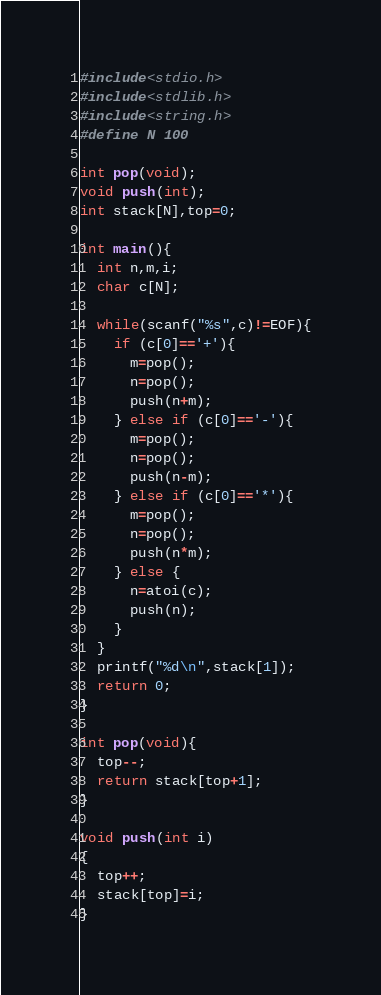Convert code to text. <code><loc_0><loc_0><loc_500><loc_500><_C_>#include<stdio.h>
#include<stdlib.h>
#include<string.h>
#define N 100
 
int pop(void);
void push(int);
int stack[N],top=0;
 
int main(){
  int n,m,i;
  char c[N];
 
  while(scanf("%s",c)!=EOF){
    if (c[0]=='+'){
      m=pop();
      n=pop();
      push(n+m);
    } else if (c[0]=='-'){
      m=pop();
      n=pop();
      push(n-m);
    } else if (c[0]=='*'){
      m=pop();
      n=pop();
      push(n*m);
    } else {
      n=atoi(c);
      push(n);
    }
  }
  printf("%d\n",stack[1]);
  return 0;
}
 
int pop(void){
  top--;
  return stack[top+1];
}
 
void push(int i)
{
  top++;
  stack[top]=i;
}</code> 